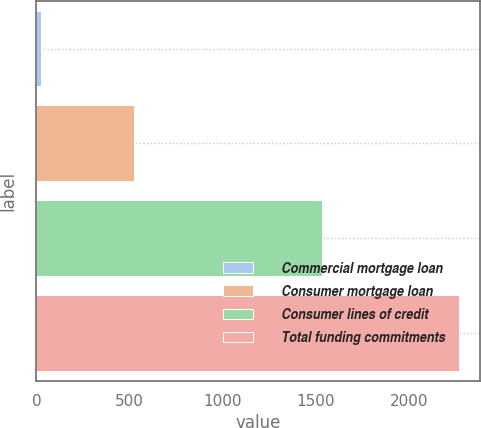<chart> <loc_0><loc_0><loc_500><loc_500><bar_chart><fcel>Commercial mortgage loan<fcel>Consumer mortgage loan<fcel>Consumer lines of credit<fcel>Total funding commitments<nl><fcel>22<fcel>525<fcel>1533<fcel>2268<nl></chart> 